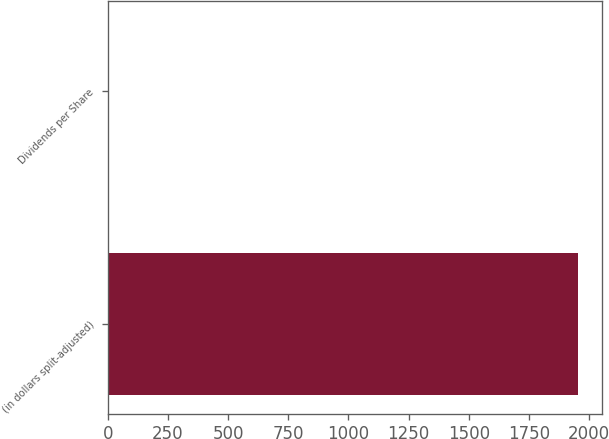<chart> <loc_0><loc_0><loc_500><loc_500><bar_chart><fcel>(in dollars split-adjusted)<fcel>Dividends per Share<nl><fcel>1956<fcel>0.01<nl></chart> 